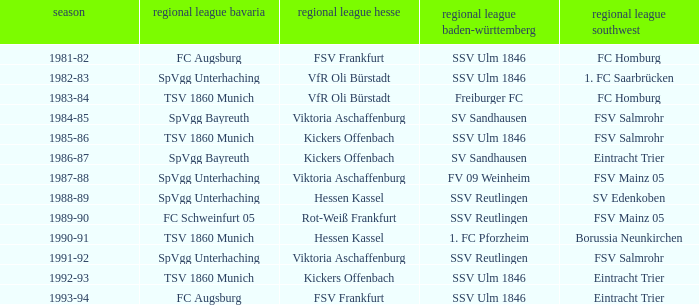Which Oberliga Baden-Württemberg has an Oberliga Hessen of fsv frankfurt in 1993-94? SSV Ulm 1846. 